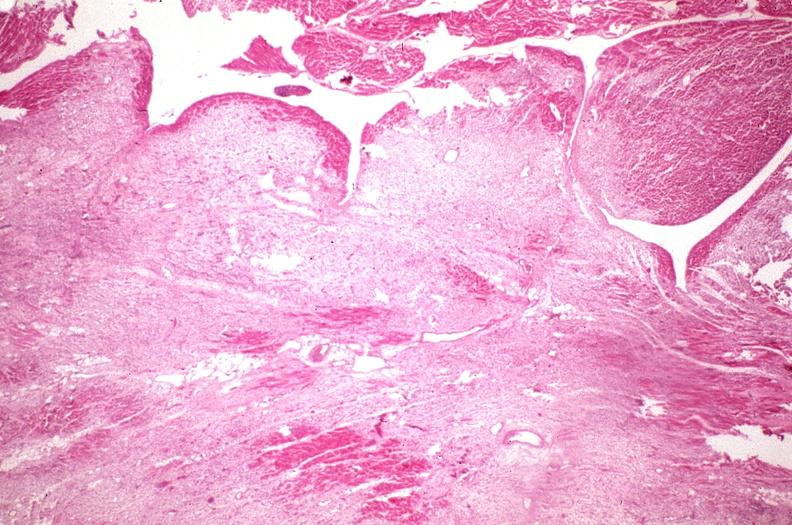what is present?
Answer the question using a single word or phrase. Cardiovascular 